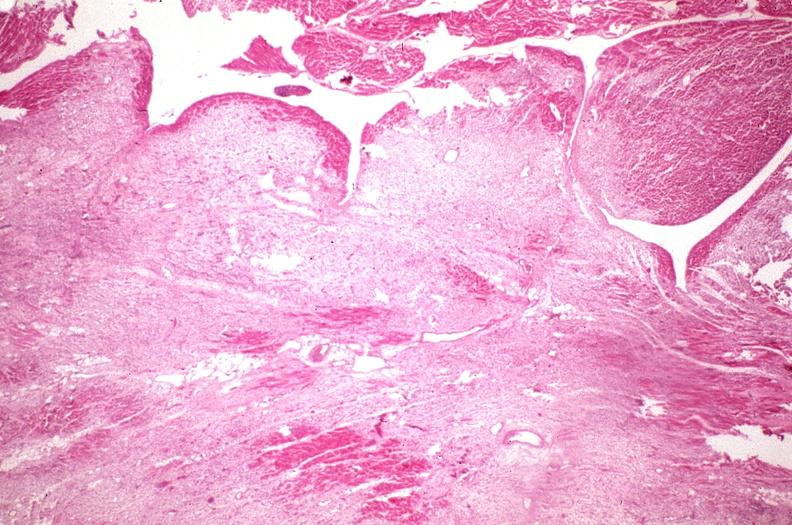what is present?
Answer the question using a single word or phrase. Cardiovascular 